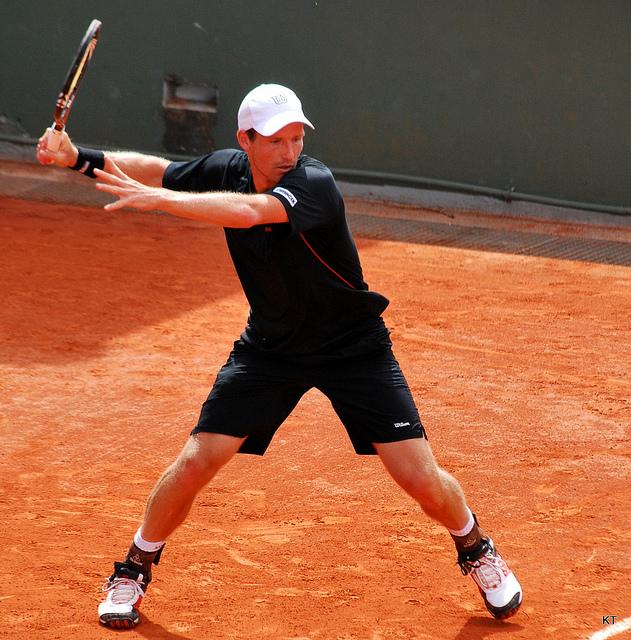What color is the stripe on his shirt?
Keep it brief. Red. Is the man holding a tennis racket?
Concise answer only. Yes. Is he standing on dirt?
Keep it brief. Yes. 